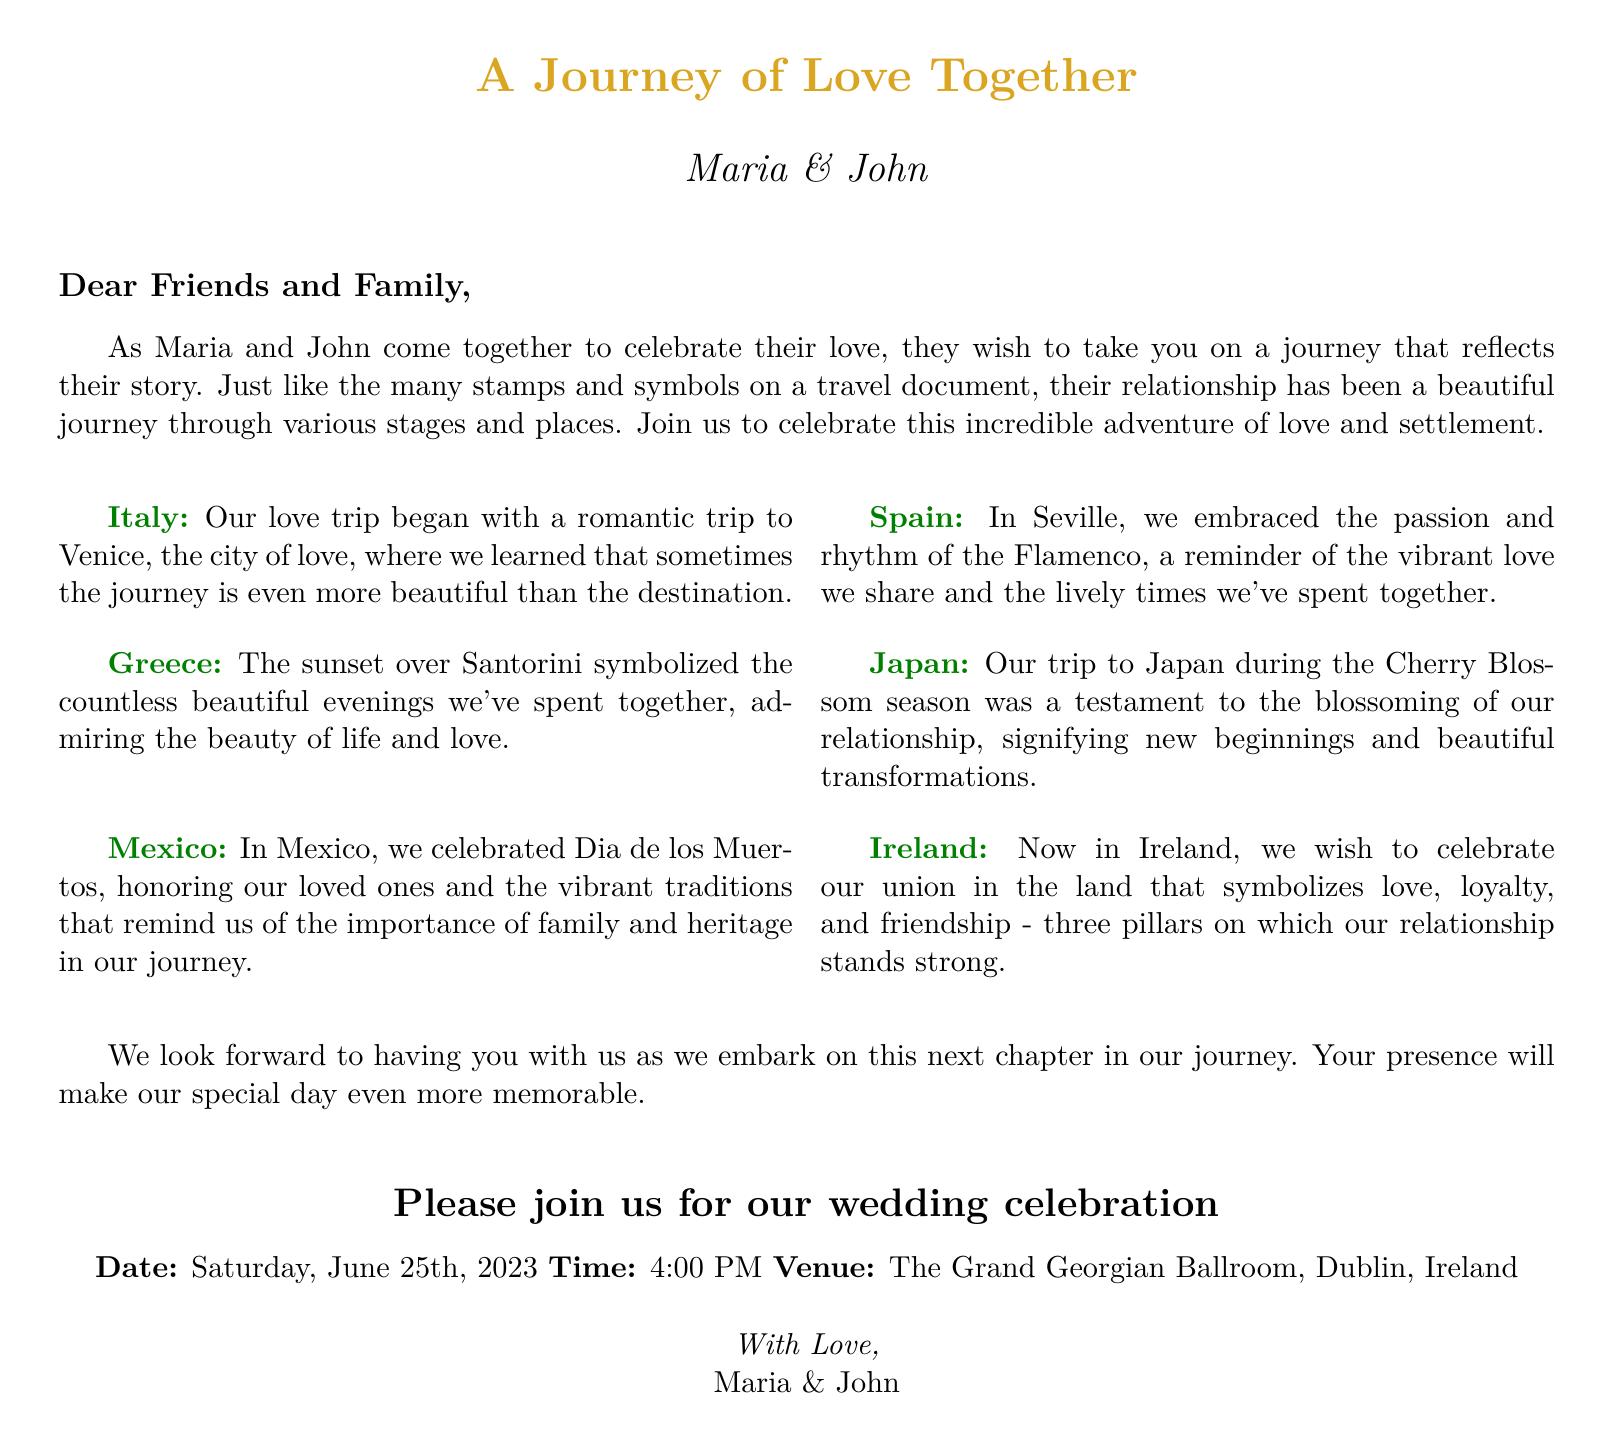What are the names of the couple? The invitation mentions the names of the couple as Maria and John.
Answer: Maria & John What is the theme of the wedding invitation? The document is designed as a travel-themed invitation, reflecting their journey of love and settlement.
Answer: Travel-themed What is the date of the wedding? The wedding is scheduled for Saturday, June 25th, 2023, as stated in the invitation.
Answer: June 25th, 2023 Which venue will host the wedding celebration? The invitation specifies that The Grand Georgian Ballroom in Dublin, Ireland is the venue for the celebration.
Answer: The Grand Georgian Ballroom, Dublin, Ireland What country is mentioned as the place of their union? The document notes that they wish to celebrate their union in Ireland, highlighting its significance.
Answer: Ireland How does the couple describe their trip to Italy? According to the document, their love trip to Italy began with a romantic trip to Venice, representing beauty in the journey.
Answer: A romantic trip to Venice What cultural event did they celebrate in Mexico? The invitation mentions that they celebrated Dia de los Muertos in Mexico, highlighting the importance of family and heritage.
Answer: Dia de los Muertos How is Japan significant to their relationship? The document states that their trip to Japan during Cherry Blossom season symbolizes the blossoming of their relationship.
Answer: Cherry Blossom season What time is the wedding ceremony scheduled to start? The time for the wedding celebration is noted as 4:00 PM in the invitation.
Answer: 4:00 PM What does the couple hope for their special day? They express that having guests present will make their special day even more memorable.
Answer: Make it more memorable 